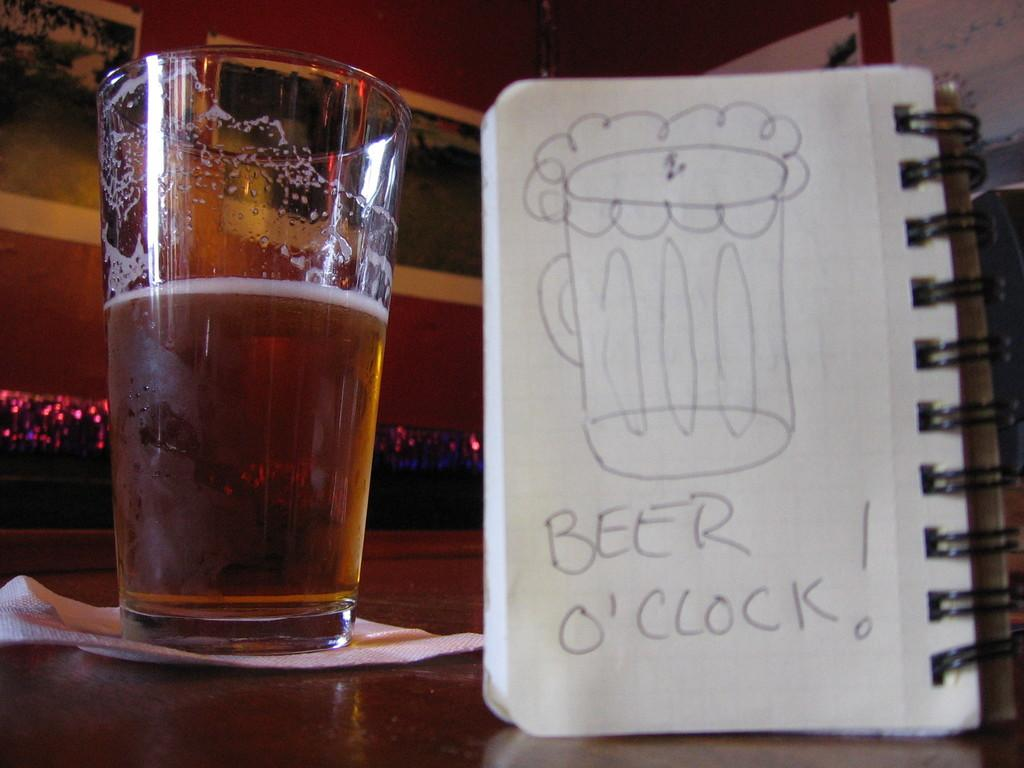Provide a one-sentence caption for the provided image. A mug of beer with a pad of paper that reads beer o'clock!. 